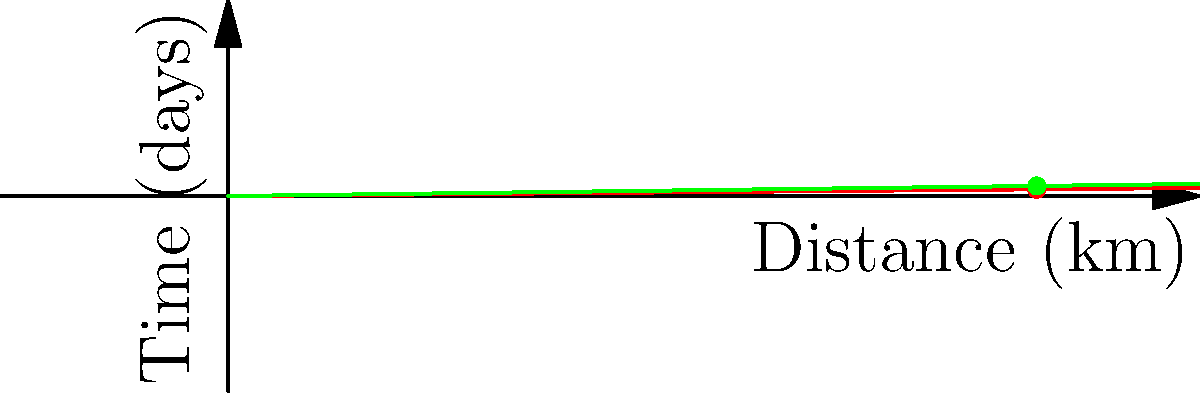Based on the velocity vectors represented in the graph for three major 18th-century trade routes from New Spain, which route had the highest average velocity? To determine which route had the highest average velocity, we need to analyze the slopes of the lines in the distance-time graph:

1. The steeper the slope, the higher the velocity.
2. Veracruz-Cádiz (blue line): 
   Slope = $\frac{1}{100}$ = 0.01 km/day
3. Acapulco-Manila (red line): 
   Slope = $\frac{1}{120}$ = 0.00833 km/day
4. Veracruz-Havana (green line): 
   Slope = $\frac{1}{80}$ = 0.0125 km/day

The Veracruz-Havana route (green line) has the steepest slope, indicating the highest average velocity.

To convert to km/h:
Veracruz-Havana: $0.0125 \times 24 = 0.3$ km/h

This higher velocity could be attributed to more favorable winds and currents in the Caribbean, as well as the shorter distance compared to trans-Atlantic or trans-Pacific routes.
Answer: Veracruz-Havana route (0.3 km/h) 